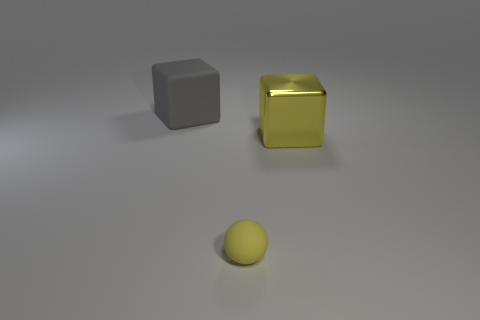Add 1 small spheres. How many objects exist? 4 Subtract all blocks. How many objects are left? 1 Add 2 matte spheres. How many matte spheres are left? 3 Add 1 cubes. How many cubes exist? 3 Subtract 1 gray blocks. How many objects are left? 2 Subtract all yellow matte objects. Subtract all small purple matte things. How many objects are left? 2 